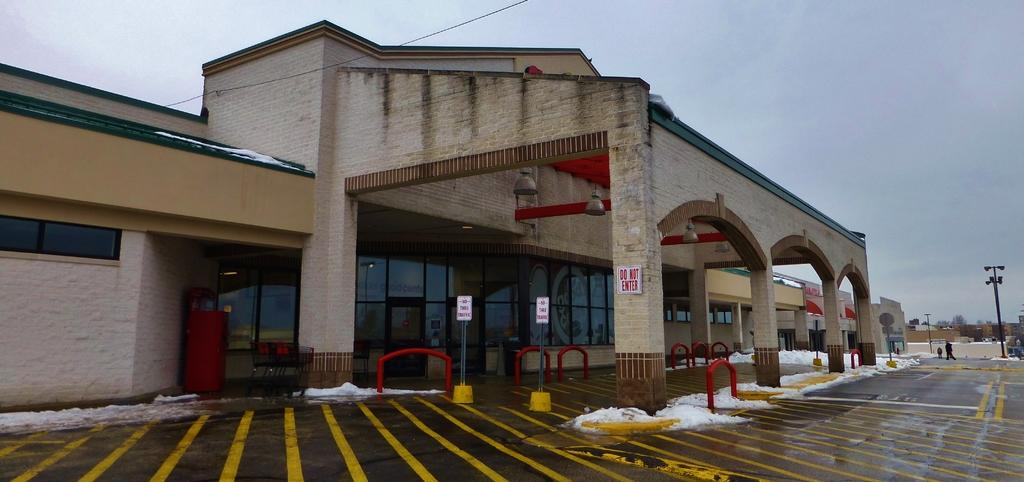Provide a one-sentence caption for the provided image. No thru traffic is allowed and a vehicle may not enter in front of a building. 